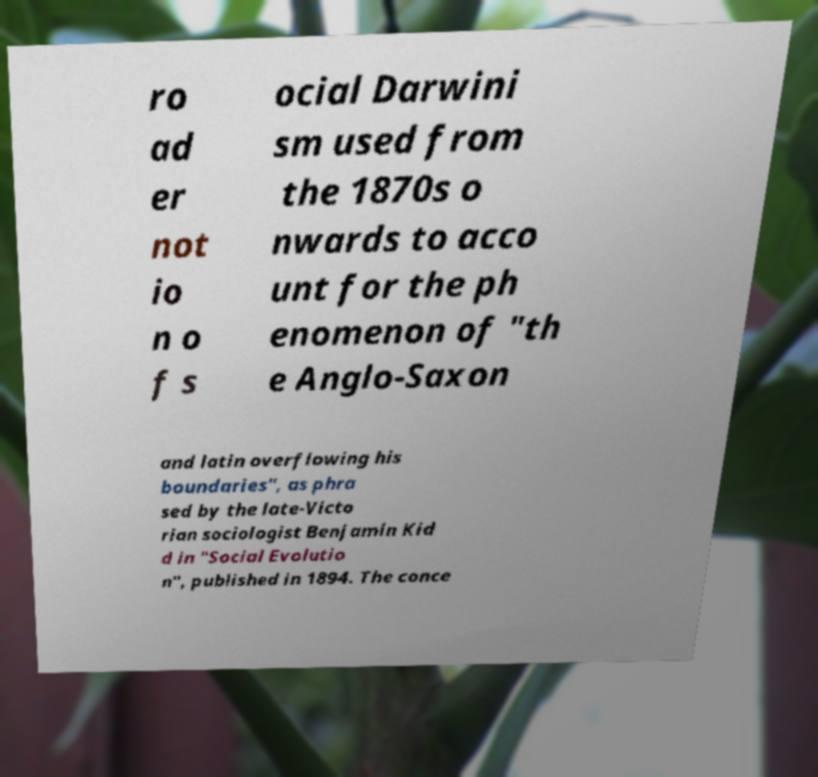For documentation purposes, I need the text within this image transcribed. Could you provide that? ro ad er not io n o f s ocial Darwini sm used from the 1870s o nwards to acco unt for the ph enomenon of "th e Anglo-Saxon and latin overflowing his boundaries", as phra sed by the late-Victo rian sociologist Benjamin Kid d in "Social Evolutio n", published in 1894. The conce 